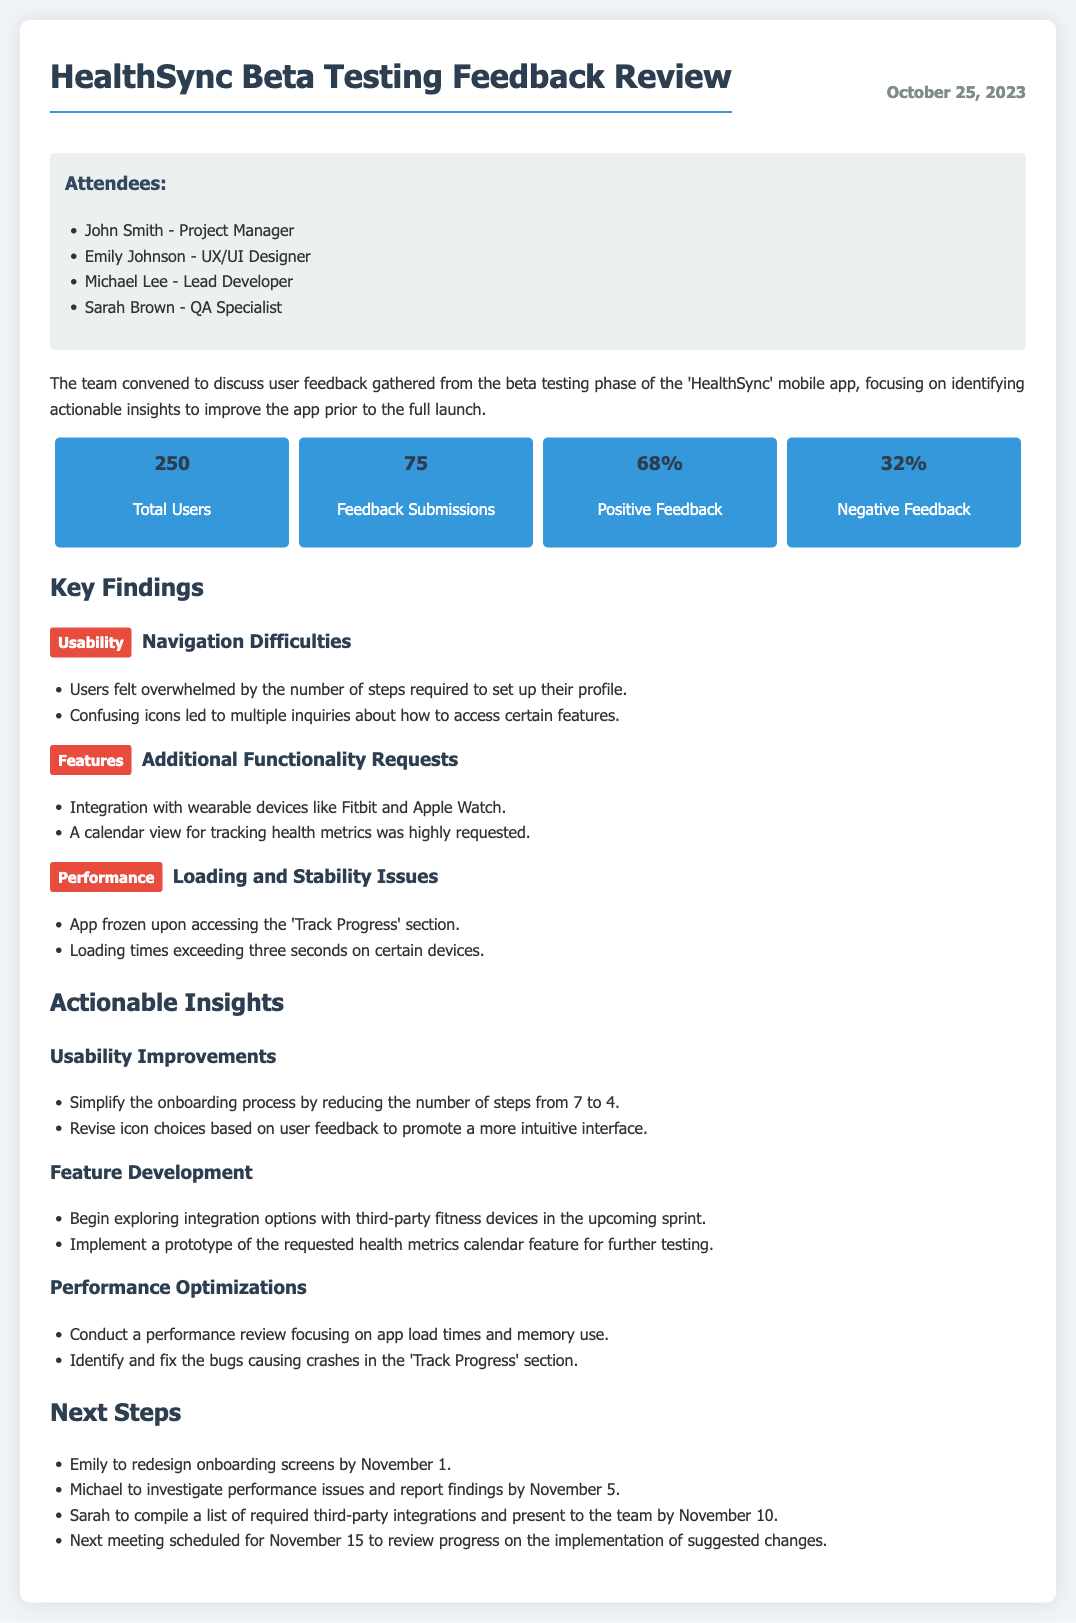what is the date of the meeting? The date of the meeting is listed in the document header as October 25, 2023.
Answer: October 25, 2023 who is the Project Manager? The Project Manager's name is mentioned in the attendees section as John Smith.
Answer: John Smith how many positive feedback submissions were received? The percentage of positive feedback is stated in the feedback overview as 68%.
Answer: 68% what is one key finding related to usability? The document lists a key finding related to usability describing problems with navigation. Specifically, users felt overwhelmed by the number of steps required to set up their profile.
Answer: Users felt overwhelmed by the number of steps required to set up their profile what is one actionable insight for performance optimization? The insights section includes a suggestion to conduct a performance review focusing on app load times and memory usage.
Answer: Conduct a performance review focusing on app load times and memory use what is the next meeting date? The date for the next meeting is specified in the next steps section as November 15.
Answer: November 15 what percentage of feedback submissions were negative? The percentage of negative feedback is provided in the feedback overview as 32%.
Answer: 32% who is responsible for investigating performance issues? The document assigns responsibility for investigating performance issues to Michael, with a report deadline of November 5.
Answer: Michael what feature development is suggested for the upcoming sprint? The document references exploring integration options with third-party fitness devices in the upcoming sprint as part of feature development.
Answer: Integration options with third-party fitness devices 